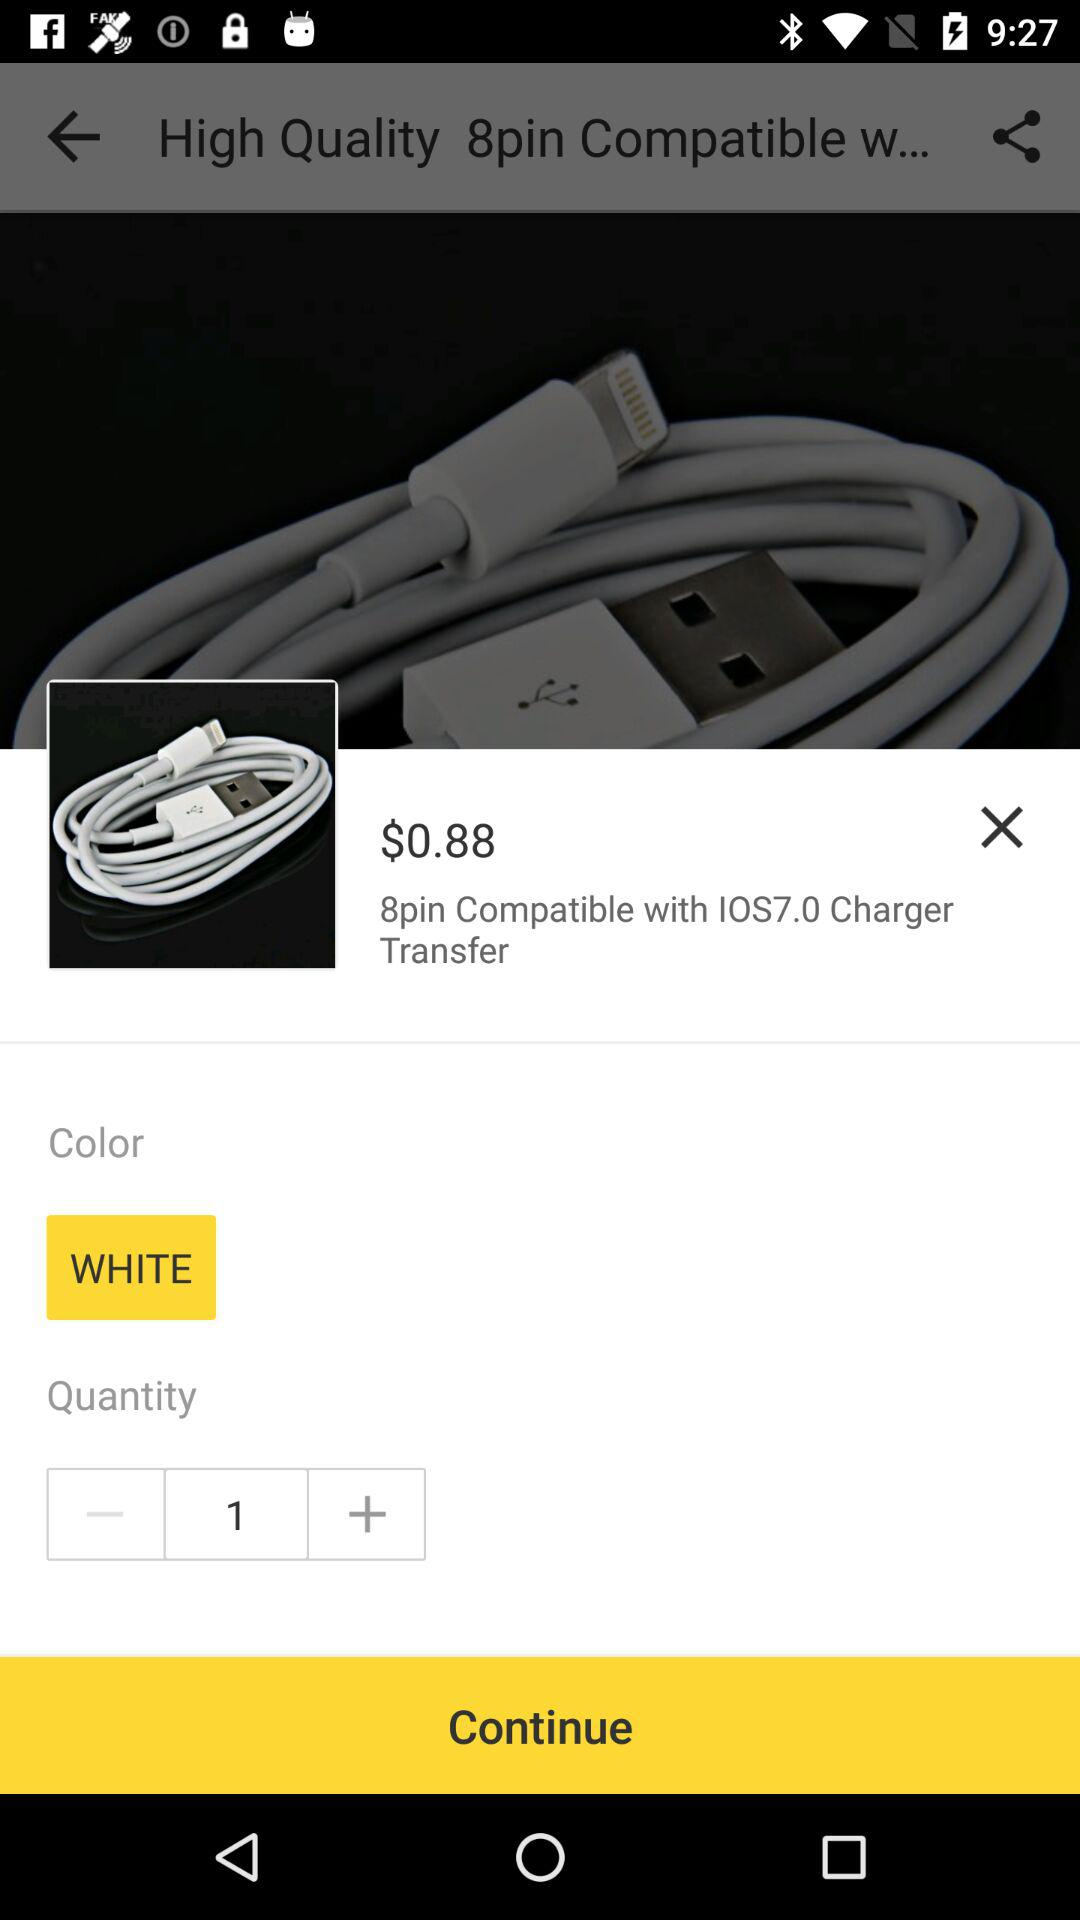What is the quantity? The quantity is 1. 